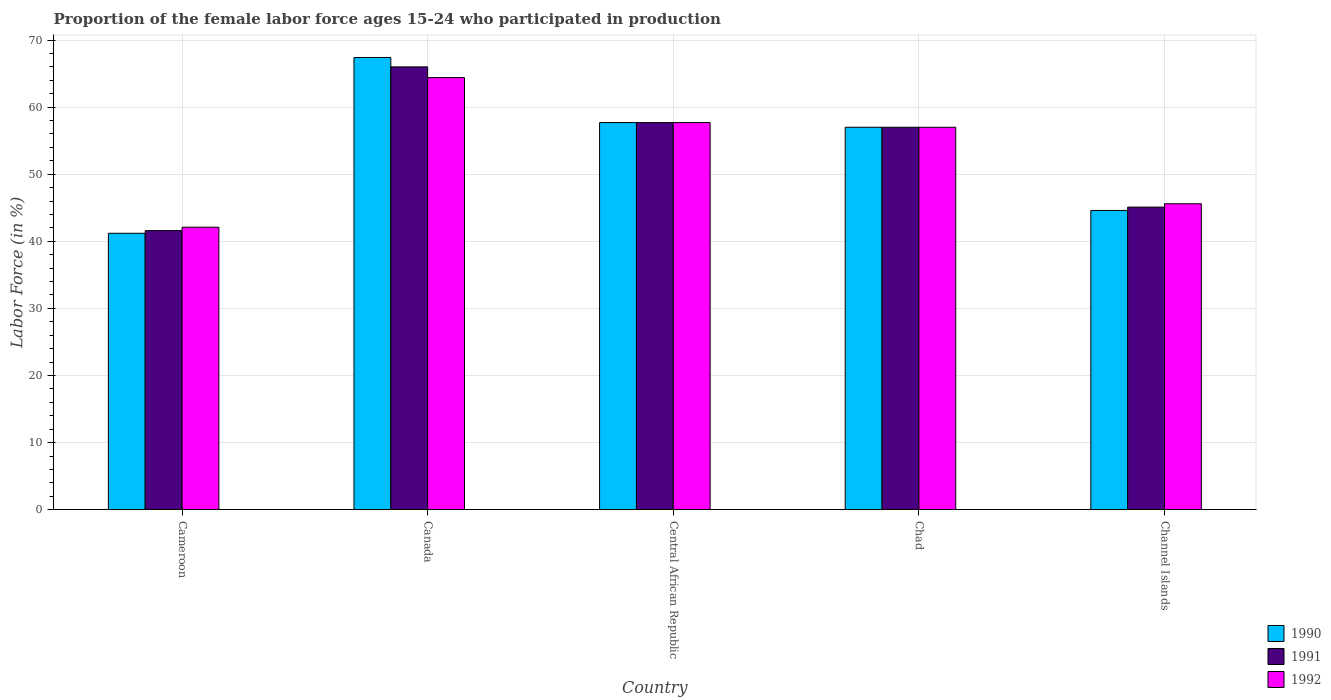How many different coloured bars are there?
Give a very brief answer. 3. Are the number of bars on each tick of the X-axis equal?
Offer a terse response. Yes. What is the label of the 4th group of bars from the left?
Your answer should be compact. Chad. In how many cases, is the number of bars for a given country not equal to the number of legend labels?
Ensure brevity in your answer.  0. What is the proportion of the female labor force who participated in production in 1992 in Central African Republic?
Offer a terse response. 57.7. Across all countries, what is the minimum proportion of the female labor force who participated in production in 1992?
Your response must be concise. 42.1. In which country was the proportion of the female labor force who participated in production in 1990 maximum?
Your answer should be very brief. Canada. In which country was the proportion of the female labor force who participated in production in 1990 minimum?
Provide a short and direct response. Cameroon. What is the total proportion of the female labor force who participated in production in 1990 in the graph?
Your answer should be very brief. 267.9. What is the difference between the proportion of the female labor force who participated in production in 1992 in Canada and that in Channel Islands?
Your response must be concise. 18.8. What is the difference between the proportion of the female labor force who participated in production in 1990 in Chad and the proportion of the female labor force who participated in production in 1992 in Cameroon?
Offer a very short reply. 14.9. What is the average proportion of the female labor force who participated in production in 1992 per country?
Keep it short and to the point. 53.36. What is the difference between the proportion of the female labor force who participated in production of/in 1991 and proportion of the female labor force who participated in production of/in 1990 in Cameroon?
Give a very brief answer. 0.4. What is the ratio of the proportion of the female labor force who participated in production in 1991 in Chad to that in Channel Islands?
Your answer should be compact. 1.26. Is the difference between the proportion of the female labor force who participated in production in 1991 in Canada and Channel Islands greater than the difference between the proportion of the female labor force who participated in production in 1990 in Canada and Channel Islands?
Offer a very short reply. No. What is the difference between the highest and the second highest proportion of the female labor force who participated in production in 1991?
Ensure brevity in your answer.  -8.3. What is the difference between the highest and the lowest proportion of the female labor force who participated in production in 1990?
Your answer should be very brief. 26.2. In how many countries, is the proportion of the female labor force who participated in production in 1990 greater than the average proportion of the female labor force who participated in production in 1990 taken over all countries?
Offer a terse response. 3. What does the 1st bar from the left in Channel Islands represents?
Your response must be concise. 1990. What does the 2nd bar from the right in Chad represents?
Give a very brief answer. 1991. Is it the case that in every country, the sum of the proportion of the female labor force who participated in production in 1990 and proportion of the female labor force who participated in production in 1992 is greater than the proportion of the female labor force who participated in production in 1991?
Provide a short and direct response. Yes. How many bars are there?
Provide a short and direct response. 15. Are all the bars in the graph horizontal?
Provide a short and direct response. No. What is the difference between two consecutive major ticks on the Y-axis?
Ensure brevity in your answer.  10. Are the values on the major ticks of Y-axis written in scientific E-notation?
Make the answer very short. No. Does the graph contain any zero values?
Offer a very short reply. No. Does the graph contain grids?
Offer a terse response. Yes. What is the title of the graph?
Keep it short and to the point. Proportion of the female labor force ages 15-24 who participated in production. What is the label or title of the X-axis?
Your answer should be very brief. Country. What is the Labor Force (in %) in 1990 in Cameroon?
Your answer should be compact. 41.2. What is the Labor Force (in %) in 1991 in Cameroon?
Offer a very short reply. 41.6. What is the Labor Force (in %) in 1992 in Cameroon?
Keep it short and to the point. 42.1. What is the Labor Force (in %) of 1990 in Canada?
Your answer should be compact. 67.4. What is the Labor Force (in %) of 1992 in Canada?
Your response must be concise. 64.4. What is the Labor Force (in %) in 1990 in Central African Republic?
Offer a very short reply. 57.7. What is the Labor Force (in %) in 1991 in Central African Republic?
Provide a succinct answer. 57.7. What is the Labor Force (in %) in 1992 in Central African Republic?
Offer a terse response. 57.7. What is the Labor Force (in %) of 1990 in Chad?
Offer a terse response. 57. What is the Labor Force (in %) of 1992 in Chad?
Provide a short and direct response. 57. What is the Labor Force (in %) in 1990 in Channel Islands?
Ensure brevity in your answer.  44.6. What is the Labor Force (in %) in 1991 in Channel Islands?
Your answer should be compact. 45.1. What is the Labor Force (in %) in 1992 in Channel Islands?
Offer a very short reply. 45.6. Across all countries, what is the maximum Labor Force (in %) in 1990?
Provide a short and direct response. 67.4. Across all countries, what is the maximum Labor Force (in %) in 1991?
Give a very brief answer. 66. Across all countries, what is the maximum Labor Force (in %) of 1992?
Your answer should be very brief. 64.4. Across all countries, what is the minimum Labor Force (in %) of 1990?
Your answer should be compact. 41.2. Across all countries, what is the minimum Labor Force (in %) of 1991?
Give a very brief answer. 41.6. Across all countries, what is the minimum Labor Force (in %) in 1992?
Your answer should be very brief. 42.1. What is the total Labor Force (in %) in 1990 in the graph?
Offer a very short reply. 267.9. What is the total Labor Force (in %) in 1991 in the graph?
Give a very brief answer. 267.4. What is the total Labor Force (in %) in 1992 in the graph?
Provide a short and direct response. 266.8. What is the difference between the Labor Force (in %) in 1990 in Cameroon and that in Canada?
Your answer should be very brief. -26.2. What is the difference between the Labor Force (in %) in 1991 in Cameroon and that in Canada?
Ensure brevity in your answer.  -24.4. What is the difference between the Labor Force (in %) of 1992 in Cameroon and that in Canada?
Your answer should be very brief. -22.3. What is the difference between the Labor Force (in %) of 1990 in Cameroon and that in Central African Republic?
Offer a very short reply. -16.5. What is the difference between the Labor Force (in %) in 1991 in Cameroon and that in Central African Republic?
Keep it short and to the point. -16.1. What is the difference between the Labor Force (in %) in 1992 in Cameroon and that in Central African Republic?
Give a very brief answer. -15.6. What is the difference between the Labor Force (in %) of 1990 in Cameroon and that in Chad?
Your response must be concise. -15.8. What is the difference between the Labor Force (in %) of 1991 in Cameroon and that in Chad?
Offer a terse response. -15.4. What is the difference between the Labor Force (in %) of 1992 in Cameroon and that in Chad?
Your response must be concise. -14.9. What is the difference between the Labor Force (in %) of 1991 in Cameroon and that in Channel Islands?
Provide a succinct answer. -3.5. What is the difference between the Labor Force (in %) of 1992 in Cameroon and that in Channel Islands?
Provide a succinct answer. -3.5. What is the difference between the Labor Force (in %) of 1991 in Canada and that in Central African Republic?
Keep it short and to the point. 8.3. What is the difference between the Labor Force (in %) in 1992 in Canada and that in Central African Republic?
Give a very brief answer. 6.7. What is the difference between the Labor Force (in %) of 1990 in Canada and that in Channel Islands?
Provide a succinct answer. 22.8. What is the difference between the Labor Force (in %) in 1991 in Canada and that in Channel Islands?
Offer a terse response. 20.9. What is the difference between the Labor Force (in %) of 1992 in Canada and that in Channel Islands?
Your answer should be very brief. 18.8. What is the difference between the Labor Force (in %) of 1990 in Central African Republic and that in Chad?
Provide a succinct answer. 0.7. What is the difference between the Labor Force (in %) of 1990 in Cameroon and the Labor Force (in %) of 1991 in Canada?
Your answer should be very brief. -24.8. What is the difference between the Labor Force (in %) of 1990 in Cameroon and the Labor Force (in %) of 1992 in Canada?
Offer a terse response. -23.2. What is the difference between the Labor Force (in %) of 1991 in Cameroon and the Labor Force (in %) of 1992 in Canada?
Offer a terse response. -22.8. What is the difference between the Labor Force (in %) in 1990 in Cameroon and the Labor Force (in %) in 1991 in Central African Republic?
Your answer should be compact. -16.5. What is the difference between the Labor Force (in %) in 1990 in Cameroon and the Labor Force (in %) in 1992 in Central African Republic?
Offer a very short reply. -16.5. What is the difference between the Labor Force (in %) in 1991 in Cameroon and the Labor Force (in %) in 1992 in Central African Republic?
Your answer should be very brief. -16.1. What is the difference between the Labor Force (in %) of 1990 in Cameroon and the Labor Force (in %) of 1991 in Chad?
Your answer should be compact. -15.8. What is the difference between the Labor Force (in %) of 1990 in Cameroon and the Labor Force (in %) of 1992 in Chad?
Give a very brief answer. -15.8. What is the difference between the Labor Force (in %) in 1991 in Cameroon and the Labor Force (in %) in 1992 in Chad?
Provide a succinct answer. -15.4. What is the difference between the Labor Force (in %) of 1991 in Cameroon and the Labor Force (in %) of 1992 in Channel Islands?
Offer a terse response. -4. What is the difference between the Labor Force (in %) in 1990 in Canada and the Labor Force (in %) in 1991 in Central African Republic?
Offer a very short reply. 9.7. What is the difference between the Labor Force (in %) of 1990 in Canada and the Labor Force (in %) of 1992 in Central African Republic?
Your answer should be very brief. 9.7. What is the difference between the Labor Force (in %) of 1990 in Canada and the Labor Force (in %) of 1991 in Chad?
Your answer should be very brief. 10.4. What is the difference between the Labor Force (in %) of 1990 in Canada and the Labor Force (in %) of 1992 in Chad?
Ensure brevity in your answer.  10.4. What is the difference between the Labor Force (in %) in 1990 in Canada and the Labor Force (in %) in 1991 in Channel Islands?
Offer a very short reply. 22.3. What is the difference between the Labor Force (in %) of 1990 in Canada and the Labor Force (in %) of 1992 in Channel Islands?
Offer a very short reply. 21.8. What is the difference between the Labor Force (in %) of 1991 in Canada and the Labor Force (in %) of 1992 in Channel Islands?
Provide a succinct answer. 20.4. What is the difference between the Labor Force (in %) of 1990 in Central African Republic and the Labor Force (in %) of 1991 in Chad?
Your response must be concise. 0.7. What is the difference between the Labor Force (in %) of 1990 in Central African Republic and the Labor Force (in %) of 1992 in Chad?
Offer a terse response. 0.7. What is the difference between the Labor Force (in %) in 1990 in Central African Republic and the Labor Force (in %) in 1991 in Channel Islands?
Make the answer very short. 12.6. What is the difference between the Labor Force (in %) of 1990 in Central African Republic and the Labor Force (in %) of 1992 in Channel Islands?
Ensure brevity in your answer.  12.1. What is the difference between the Labor Force (in %) of 1991 in Central African Republic and the Labor Force (in %) of 1992 in Channel Islands?
Offer a terse response. 12.1. What is the difference between the Labor Force (in %) in 1990 in Chad and the Labor Force (in %) in 1991 in Channel Islands?
Provide a succinct answer. 11.9. What is the average Labor Force (in %) in 1990 per country?
Your answer should be compact. 53.58. What is the average Labor Force (in %) of 1991 per country?
Your response must be concise. 53.48. What is the average Labor Force (in %) in 1992 per country?
Offer a very short reply. 53.36. What is the difference between the Labor Force (in %) in 1991 and Labor Force (in %) in 1992 in Cameroon?
Provide a short and direct response. -0.5. What is the difference between the Labor Force (in %) in 1990 and Labor Force (in %) in 1992 in Canada?
Your answer should be very brief. 3. What is the difference between the Labor Force (in %) in 1991 and Labor Force (in %) in 1992 in Canada?
Offer a terse response. 1.6. What is the difference between the Labor Force (in %) in 1990 and Labor Force (in %) in 1991 in Central African Republic?
Offer a terse response. 0. What is the difference between the Labor Force (in %) of 1990 and Labor Force (in %) of 1992 in Central African Republic?
Provide a short and direct response. 0. What is the difference between the Labor Force (in %) of 1990 and Labor Force (in %) of 1992 in Chad?
Give a very brief answer. 0. What is the difference between the Labor Force (in %) in 1991 and Labor Force (in %) in 1992 in Chad?
Your answer should be very brief. 0. What is the difference between the Labor Force (in %) of 1990 and Labor Force (in %) of 1991 in Channel Islands?
Provide a succinct answer. -0.5. What is the ratio of the Labor Force (in %) of 1990 in Cameroon to that in Canada?
Your response must be concise. 0.61. What is the ratio of the Labor Force (in %) in 1991 in Cameroon to that in Canada?
Offer a terse response. 0.63. What is the ratio of the Labor Force (in %) in 1992 in Cameroon to that in Canada?
Give a very brief answer. 0.65. What is the ratio of the Labor Force (in %) in 1990 in Cameroon to that in Central African Republic?
Ensure brevity in your answer.  0.71. What is the ratio of the Labor Force (in %) of 1991 in Cameroon to that in Central African Republic?
Provide a succinct answer. 0.72. What is the ratio of the Labor Force (in %) in 1992 in Cameroon to that in Central African Republic?
Offer a terse response. 0.73. What is the ratio of the Labor Force (in %) of 1990 in Cameroon to that in Chad?
Your answer should be very brief. 0.72. What is the ratio of the Labor Force (in %) in 1991 in Cameroon to that in Chad?
Give a very brief answer. 0.73. What is the ratio of the Labor Force (in %) of 1992 in Cameroon to that in Chad?
Provide a succinct answer. 0.74. What is the ratio of the Labor Force (in %) in 1990 in Cameroon to that in Channel Islands?
Provide a succinct answer. 0.92. What is the ratio of the Labor Force (in %) in 1991 in Cameroon to that in Channel Islands?
Ensure brevity in your answer.  0.92. What is the ratio of the Labor Force (in %) in 1992 in Cameroon to that in Channel Islands?
Keep it short and to the point. 0.92. What is the ratio of the Labor Force (in %) in 1990 in Canada to that in Central African Republic?
Your answer should be very brief. 1.17. What is the ratio of the Labor Force (in %) in 1991 in Canada to that in Central African Republic?
Offer a very short reply. 1.14. What is the ratio of the Labor Force (in %) in 1992 in Canada to that in Central African Republic?
Make the answer very short. 1.12. What is the ratio of the Labor Force (in %) of 1990 in Canada to that in Chad?
Your response must be concise. 1.18. What is the ratio of the Labor Force (in %) in 1991 in Canada to that in Chad?
Your response must be concise. 1.16. What is the ratio of the Labor Force (in %) in 1992 in Canada to that in Chad?
Provide a succinct answer. 1.13. What is the ratio of the Labor Force (in %) of 1990 in Canada to that in Channel Islands?
Make the answer very short. 1.51. What is the ratio of the Labor Force (in %) of 1991 in Canada to that in Channel Islands?
Give a very brief answer. 1.46. What is the ratio of the Labor Force (in %) in 1992 in Canada to that in Channel Islands?
Your answer should be very brief. 1.41. What is the ratio of the Labor Force (in %) of 1990 in Central African Republic to that in Chad?
Give a very brief answer. 1.01. What is the ratio of the Labor Force (in %) in 1991 in Central African Republic to that in Chad?
Provide a short and direct response. 1.01. What is the ratio of the Labor Force (in %) of 1992 in Central African Republic to that in Chad?
Provide a succinct answer. 1.01. What is the ratio of the Labor Force (in %) of 1990 in Central African Republic to that in Channel Islands?
Make the answer very short. 1.29. What is the ratio of the Labor Force (in %) in 1991 in Central African Republic to that in Channel Islands?
Keep it short and to the point. 1.28. What is the ratio of the Labor Force (in %) in 1992 in Central African Republic to that in Channel Islands?
Your answer should be very brief. 1.27. What is the ratio of the Labor Force (in %) of 1990 in Chad to that in Channel Islands?
Offer a very short reply. 1.28. What is the ratio of the Labor Force (in %) in 1991 in Chad to that in Channel Islands?
Offer a very short reply. 1.26. What is the ratio of the Labor Force (in %) in 1992 in Chad to that in Channel Islands?
Your answer should be compact. 1.25. What is the difference between the highest and the second highest Labor Force (in %) of 1991?
Your answer should be compact. 8.3. What is the difference between the highest and the second highest Labor Force (in %) in 1992?
Your response must be concise. 6.7. What is the difference between the highest and the lowest Labor Force (in %) in 1990?
Keep it short and to the point. 26.2. What is the difference between the highest and the lowest Labor Force (in %) of 1991?
Your answer should be compact. 24.4. What is the difference between the highest and the lowest Labor Force (in %) of 1992?
Make the answer very short. 22.3. 